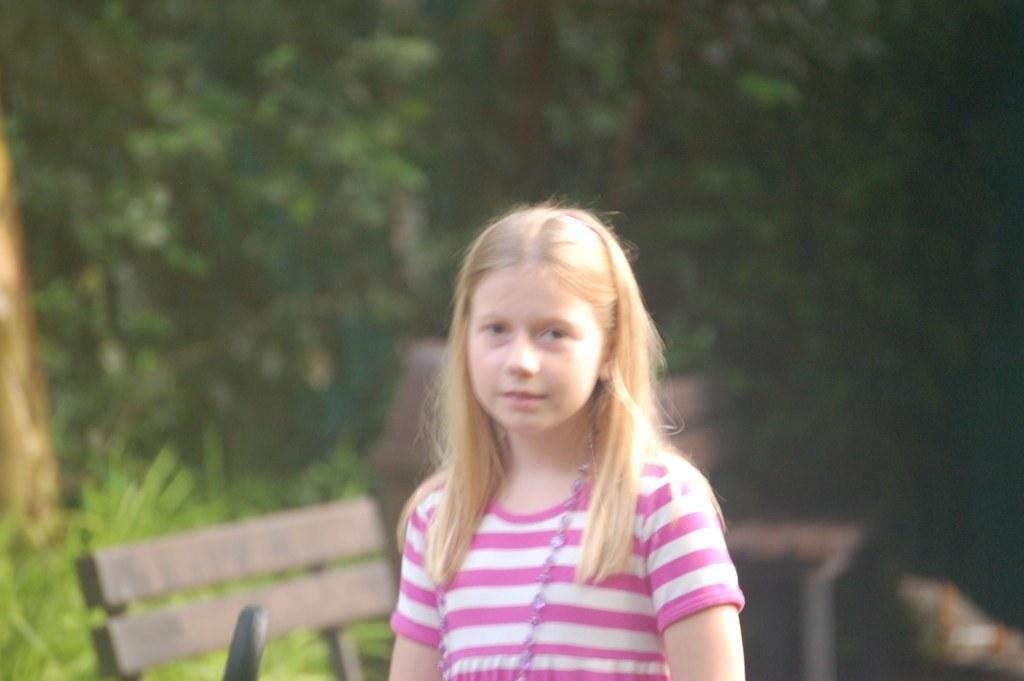Describe this image in one or two sentences. In this image I can see the person and the person is wearing pink and white color dress. In the background I can see few benches and few trees in green color. 